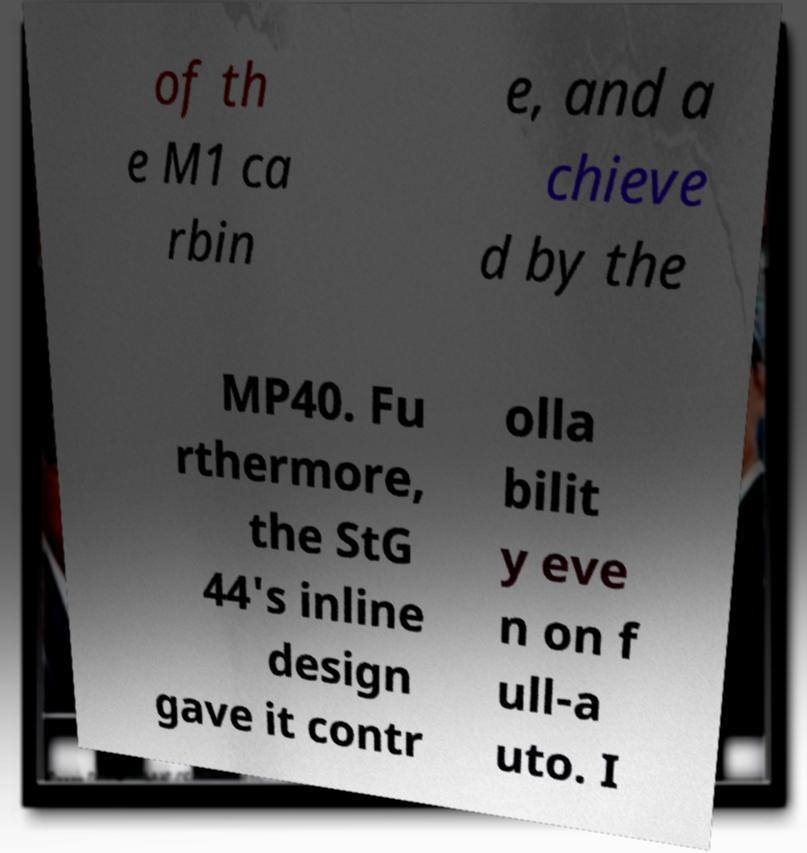There's text embedded in this image that I need extracted. Can you transcribe it verbatim? of th e M1 ca rbin e, and a chieve d by the MP40. Fu rthermore, the StG 44's inline design gave it contr olla bilit y eve n on f ull-a uto. I 